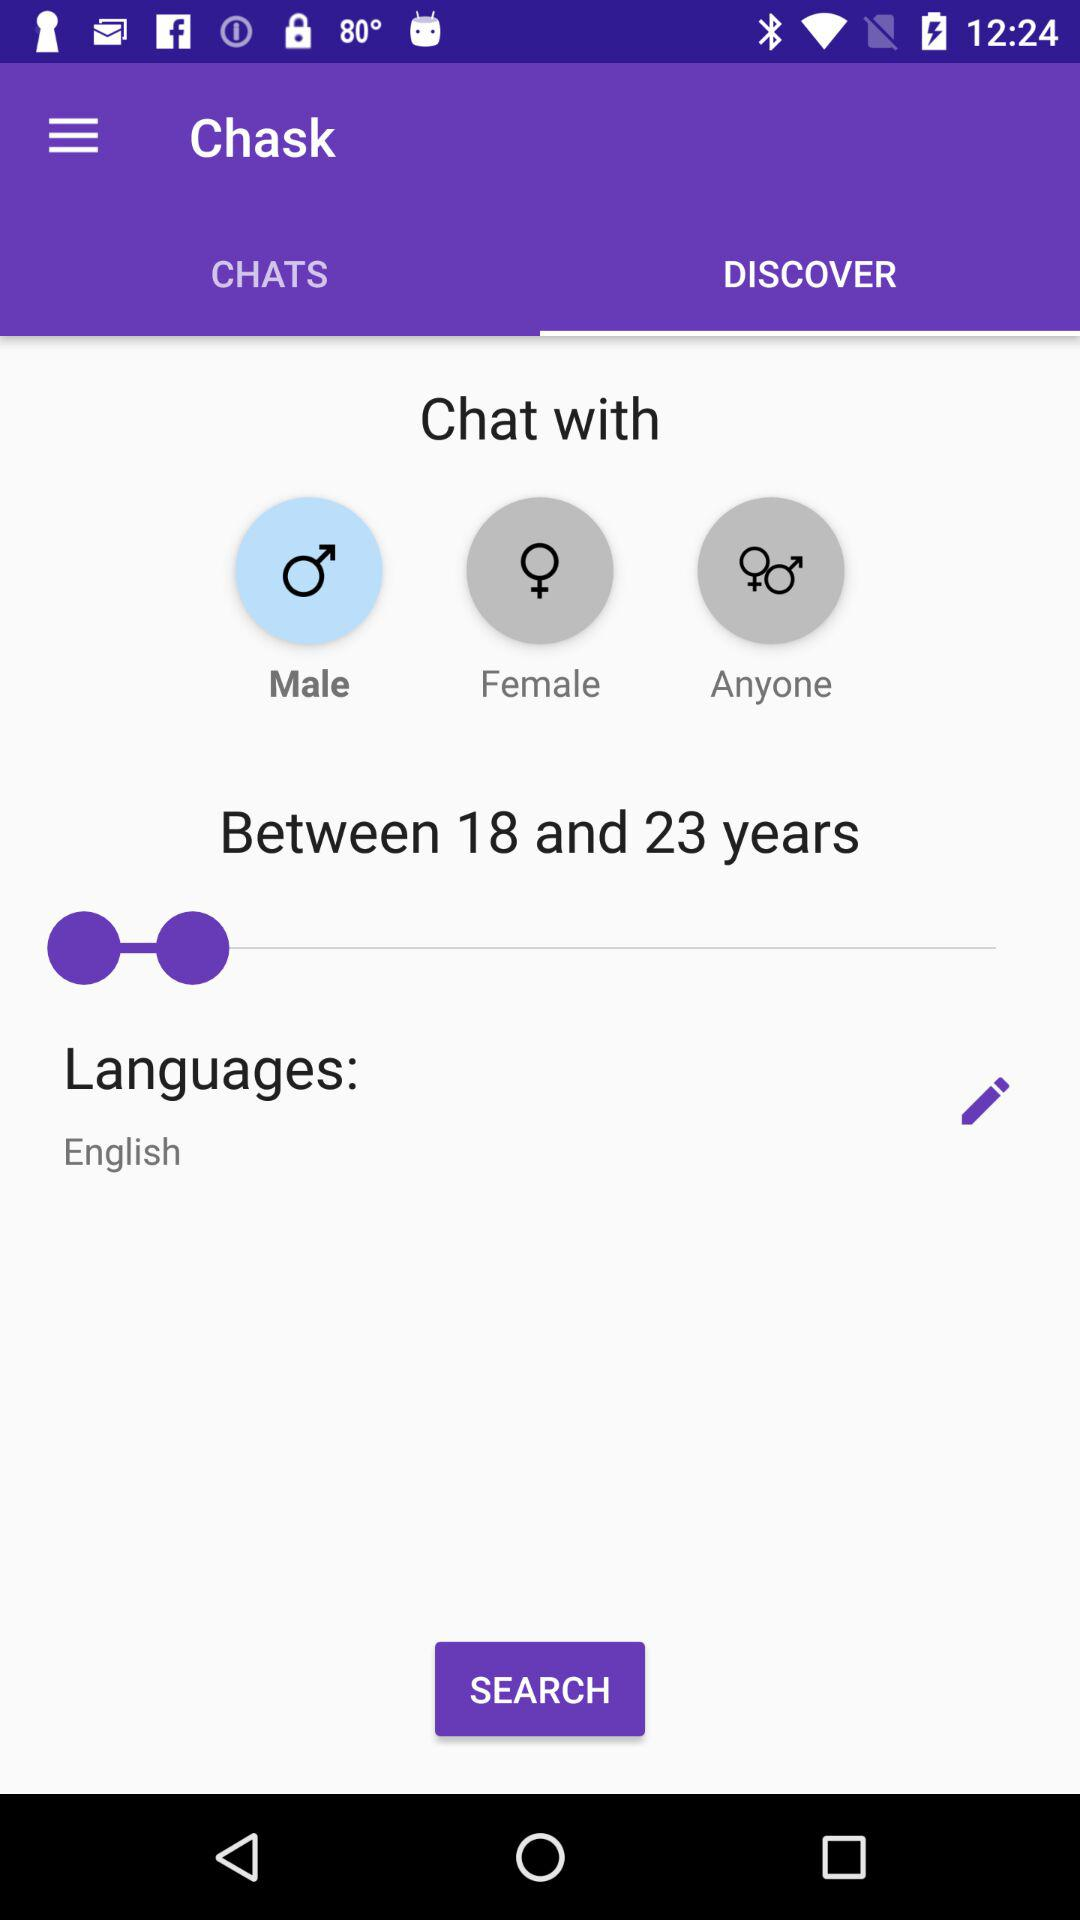How many options are available for gender?
Answer the question using a single word or phrase. 3 